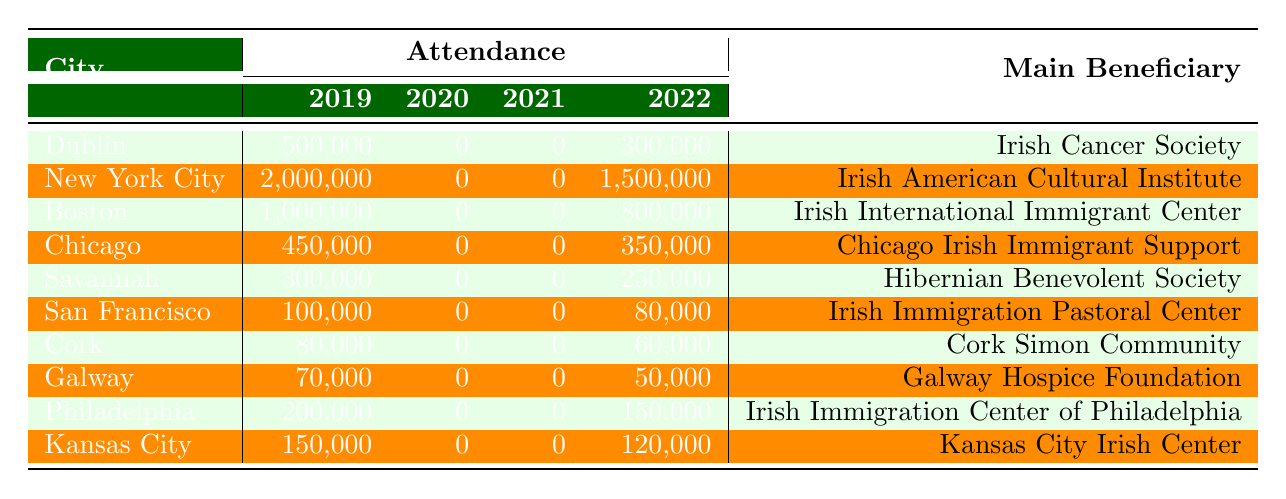What city had the highest attendance in 2019? Looking at the column for attendance in 2019, New York City has the highest figure at 2,000,000.
Answer: New York City Which city raised the least amount of funds in 2022? In the funds raised for 2022, the city with the lowest total is Cork, which raised 150,000.
Answer: Cork What was the total attendance for all cities in 2022? To find the total attendance for 2022, we add the attendance figures: 300,000 + 1,500,000 + 800,000 + 350,000 + 250,000 + 80,000 + 60,000 + 50,000 + 150,000 + 120,000 = 3,640,000.
Answer: 3,640,000 Did attendance in 2022 exceed attendance in 2019 for any city? We compare attendance figures for 2019 and 2022 for each city. Dublin, Chicago, Savannah, San Francisco, Cork, Galway, Philadelphia, and Kansas City had lower attendance in 2022 than in 2019, while New York City and Boston had higher attendance in 2022.
Answer: Yes What was the change in funds raised from 2019 to 2022 for Boston? For Boston, the funds raised in 2019 are 2,500,000 and in 2022 are 2,000,000. The change is 2,000,000 - 2,500,000 = -500,000, indicating a decrease.
Answer: Decrease of 500,000 Which city's main beneficiary is the Cork Simon Community? In the table, it is stated that the main beneficiary for Cork is the Cork Simon Community.
Answer: Cork What is the average attendance across all cities in 2022? To calculate the average attendance in 2022, we sum the attendance figures (3,640,000) and divide by the number of cities (10): 3,640,000 / 10 = 364,000.
Answer: 364,000 Which year had the lowest attendance figures across all cities? The attendance figures for 2020 and 2021 are all 0 for each city. Therefore, both years had the lowest attendance.
Answer: 2020 and 2021 What was the total amount of funds raised in 2020? To find the total funds raised in 2020, we sum the figures: 50,000 + 100,000 + 80,000 + 60,000 + 40,000 + 30,000 + 20,000 + 15,000 + 70,000 + 50,000 = 505,000.
Answer: 505,000 Which city experienced no attendance in 2020 and 2021? By examining the attendance figures for 2020 and 2021, all cities show 0 attendance these years.
Answer: All cities 